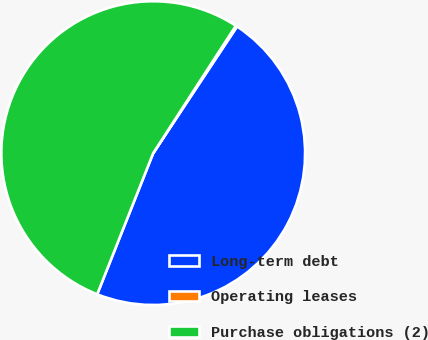Convert chart to OTSL. <chart><loc_0><loc_0><loc_500><loc_500><pie_chart><fcel>Long-term debt<fcel>Operating leases<fcel>Purchase obligations (2)<nl><fcel>46.71%<fcel>0.15%<fcel>53.15%<nl></chart> 